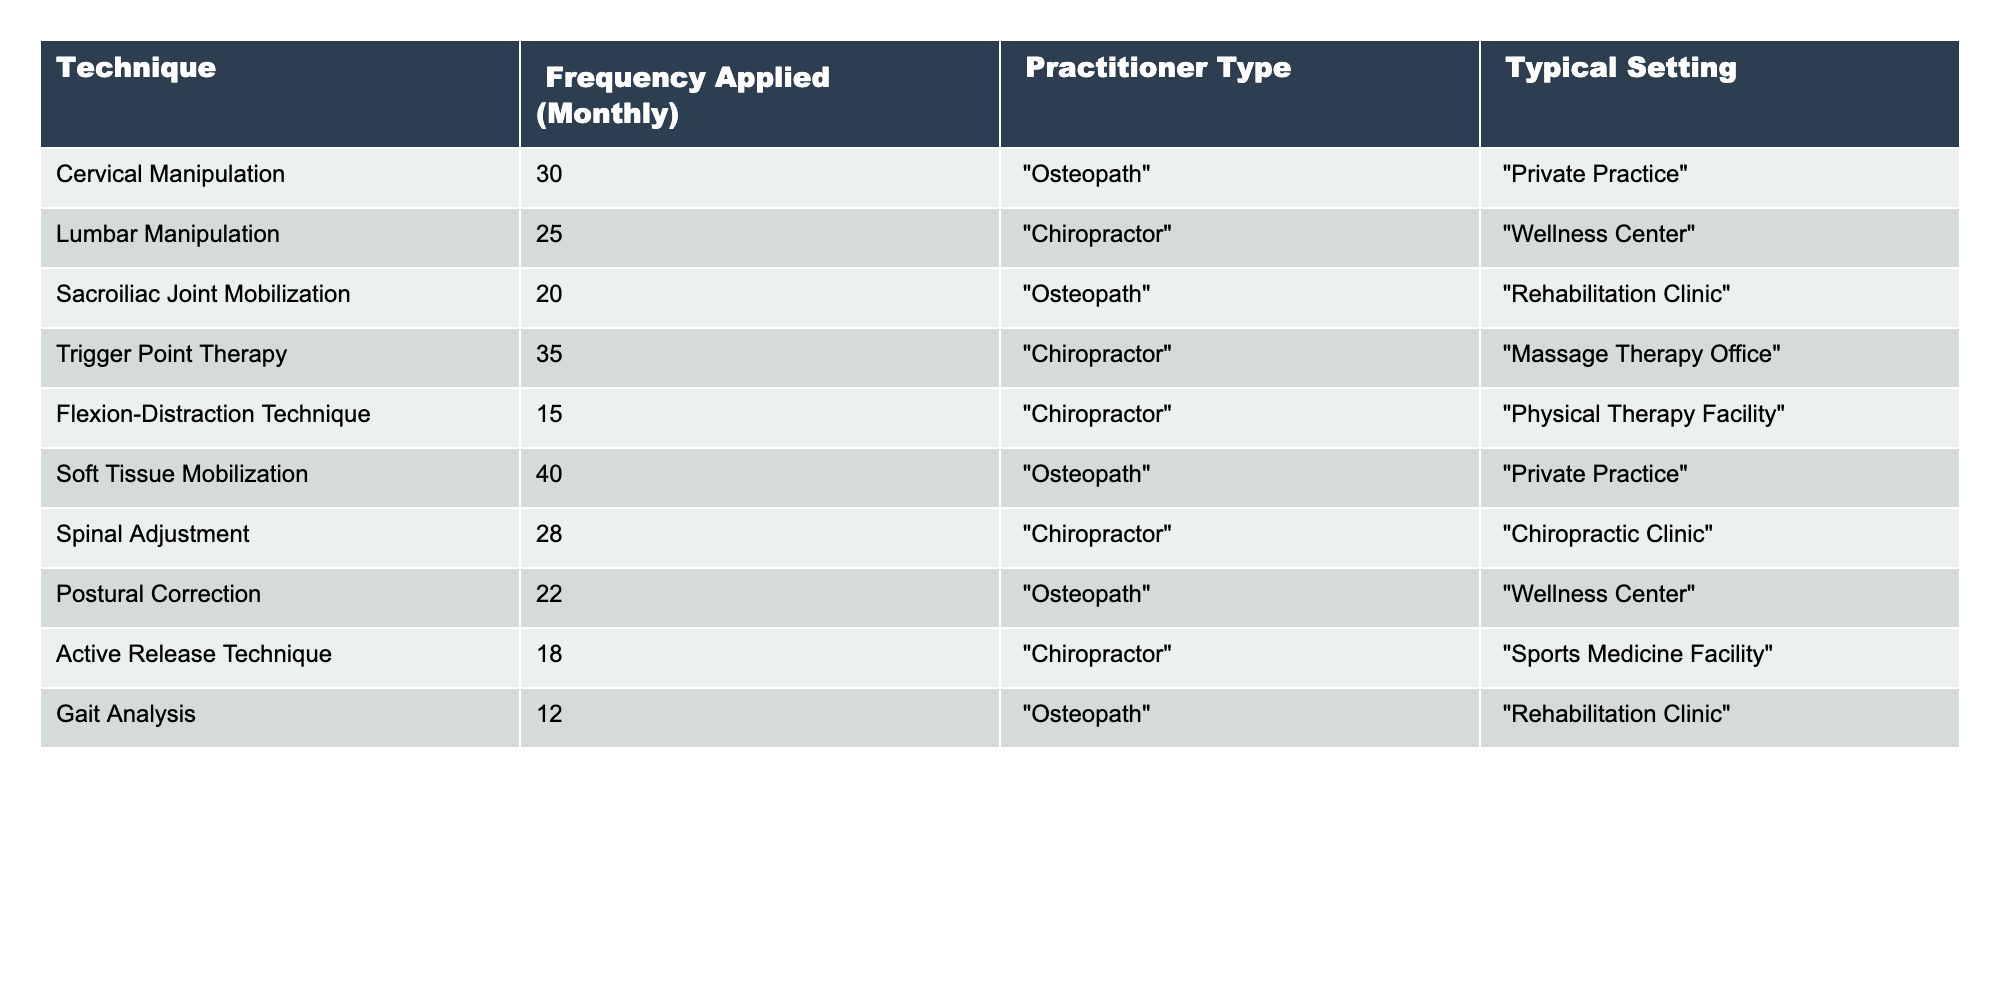What is the highest frequency of chiropractic techniques applied in osteopathic practices? The highest frequency in the table is recorded for "Soft Tissue Mobilization" with a value of 40.
Answer: 40 What technique has the second-highest frequency among osteopaths? After "Soft Tissue Mobilization", the next highest technique for osteopaths is "Cervical Manipulation" with a frequency of 30.
Answer: 30 How many techniques are applied with a frequency of more than 20? By examining the table, the techniques with frequencies greater than 20 are "Cervical Manipulation" (30), "Soft Tissue Mobilization" (40), "Postural Correction" (22), and "Trigger Point Therapy" (35), totaling 4 techniques.
Answer: 4 Is "Gait Analysis" more frequently applied than "Flexion-Distraction Technique"? "Gait Analysis" has a frequency of 12 while "Flexion-Distraction Technique" has a frequency of 15, so "Gait Analysis" is applied less frequently.
Answer: No What is the total frequency of chiropractic techniques applied by osteopaths? The frequencies for osteopaths are 30 (Cervical Manipulation), 20 (Sacroiliac Joint Mobilization), 40 (Soft Tissue Mobilization), and 22 (Postural Correction). Adding these gives 30 + 20 + 40 + 22 = 112.
Answer: 112 What is the average frequency of applied techniques for chiropractors? The frequencies for chiropractors are 25 (Lumbar Manipulation), 35 (Trigger Point Therapy), 15 (Flexion-Distraction Technique), 28 (Spinal Adjustment), and 18 (Active Release Technique). The total is 25 + 35 + 15 + 28 + 18 = 121. There are 5 techniques, so the average is 121 / 5 = 24.2.
Answer: 24.2 Which technique has the lowest frequency, and who typically applies it? The technique with the lowest frequency is "Gait Analysis" at 12, and it is typically applied by osteopaths.
Answer: Gait Analysis, osteopath What setting is most associated with high-frequency chiropractic techniques among osteopaths? "Soft Tissue Mobilization" and "Cervical Manipulation" have high frequencies (40 and 30 respectively) and both are associated with "Private Practice".
Answer: Private Practice Which practitioner type applies the highest variety of techniques? Both osteopaths and chiropractors have four techniques listed, showing they apply a similar variety.
Answer: Tie (both apply 4 techniques) Is the total frequency of chiropractor-applied techniques higher than that of osteopaths? The total frequency for chiropractors is 121, while for osteopaths is 112. Since 121 is greater than 112, chiropractors apply techniques more frequently in total.
Answer: Yes 